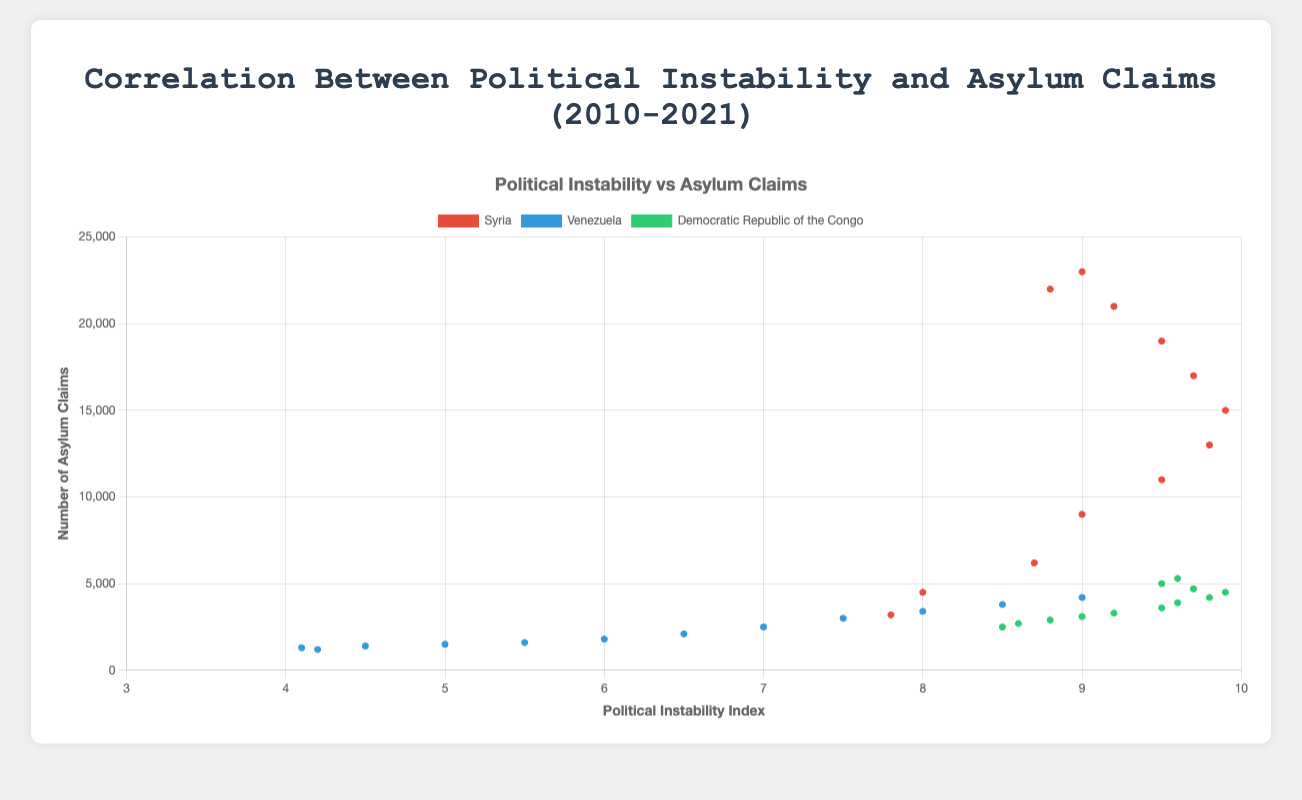Which country had the highest political instability index in 2020? The scatter plot shows data points representing the political instability index and asylum claims for different countries across various years. Find the data point for 2020 and identify the country with the highest political instability index.
Answer: Democratic Republic of the Congo How did asylum claims for Syria change from 2010 to 2021? Look for the data points representing Syria in 2010 and 2021 in the scatter plot. Compare the number of asylum claims between these two years.
Answer: Increased from 3,200 to 23,000 Which country has the most consistent trend between political instability and asylum claims from 2010 to 2021? Examine the scatter plot trends for each country (Syria, Venezuela, Democratic Republic of the Congo). Identify the country where the trend line of political instability versus asylum claims is the most consistent.
Answer: Syria Compare the asylum claims for Venezuela and the Democratic Republic of the Congo in 2019. Which country had more? Locate the 2019 data points for both Venezuela and the Democratic Republic of the Congo. Compare the number of asylum claims for each country.
Answer: Democratic Republic of the Congo What was the highest number of asylum claims for Syria, and in which year did it occur? Identify the peak data point for Syria in terms of asylum claims and note the corresponding year.
Answer: 23,000 in 2021 What is the difference in political instability index between Syria and Venezuela in 2020? Check the scatter plot for the data points representing Syria and Venezuela in 2020 and calculate the difference in their political instability indices.
Answer: 0.3 (Syria 8.8 - Venezuela 8.5) During which year did the Democratic Republic of the Congo have the largest increase in asylum claims, and by how much? Track the yearly changes in asylum claims for the Democratic Republic of the Congo to identify the year with the largest increase. Calculate the difference in claims compared to the previous year.
Answer: 2017, by 300 claims (Delta from 2016) In 2018, which country had the closest political instability index values, and what were the indices? Find the 2018 data points and compare the political instability indices for all countries. Identify the countries with the closest values.
Answer: Syria 9.5 and Democratic Republic of the Congo 9.9 What is the average political instability index for Venezuela from 2010 to 2021? Sum up the political instability indices for Venezuela across all years from 2010 to 2021 and divide by the number of years (12).
Answer: 6.0 